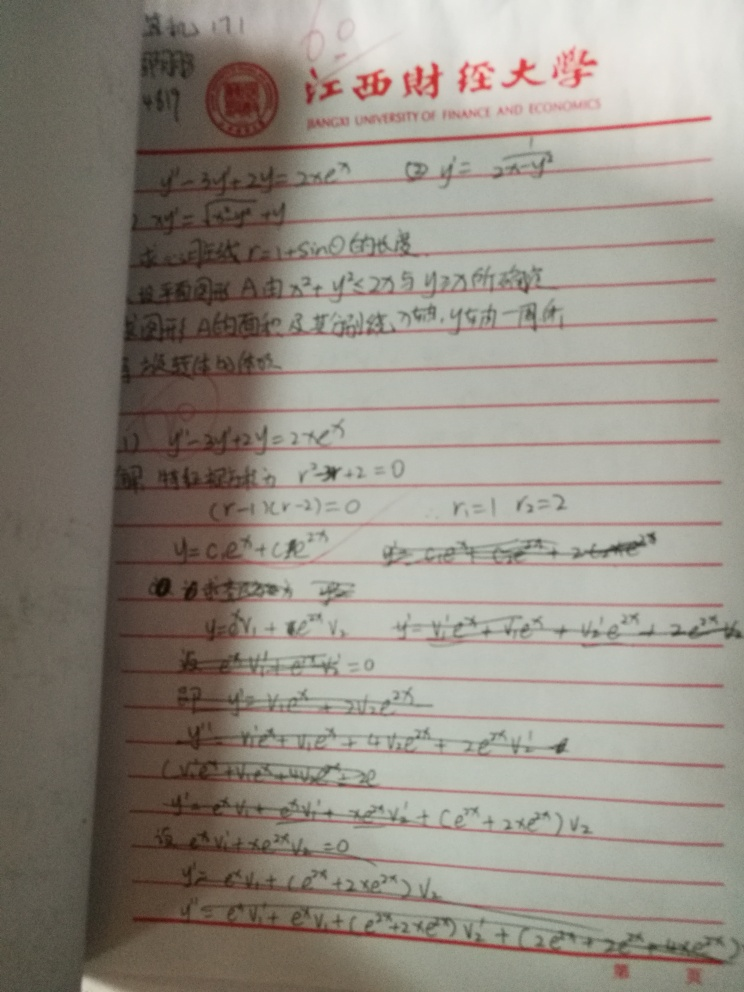Are there any quality issues with this image? Yes, the image exhibits several quality issues including blurriness and skewed perspective, making the handwritten text difficult to read. This could significantly affect its usability for educational or reference purposes, where clear visibility of details is crucial. 